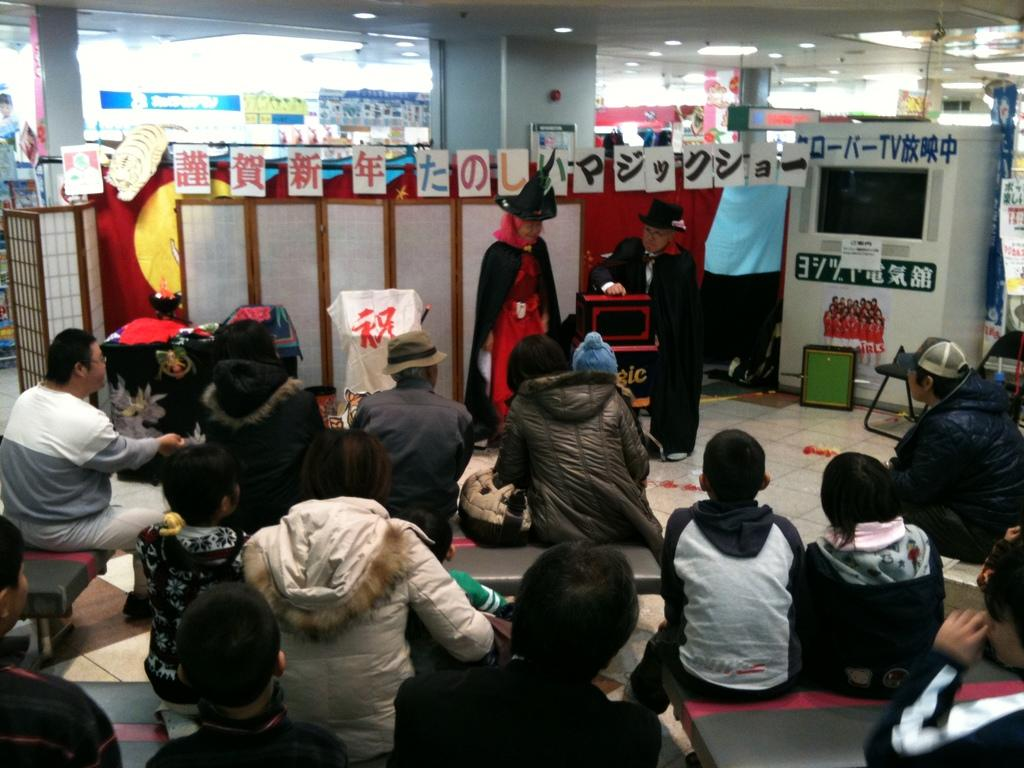What are the people in the image doing? The people are sitting on benches and watching a magic performance. Can you describe the setting of the image? There is a wall visible in the image, and there are other unspecified objects or elements in the background. What language is the potato speaking during the magic performance? There is no potato present in the image, and therefore it cannot be speaking any language. 